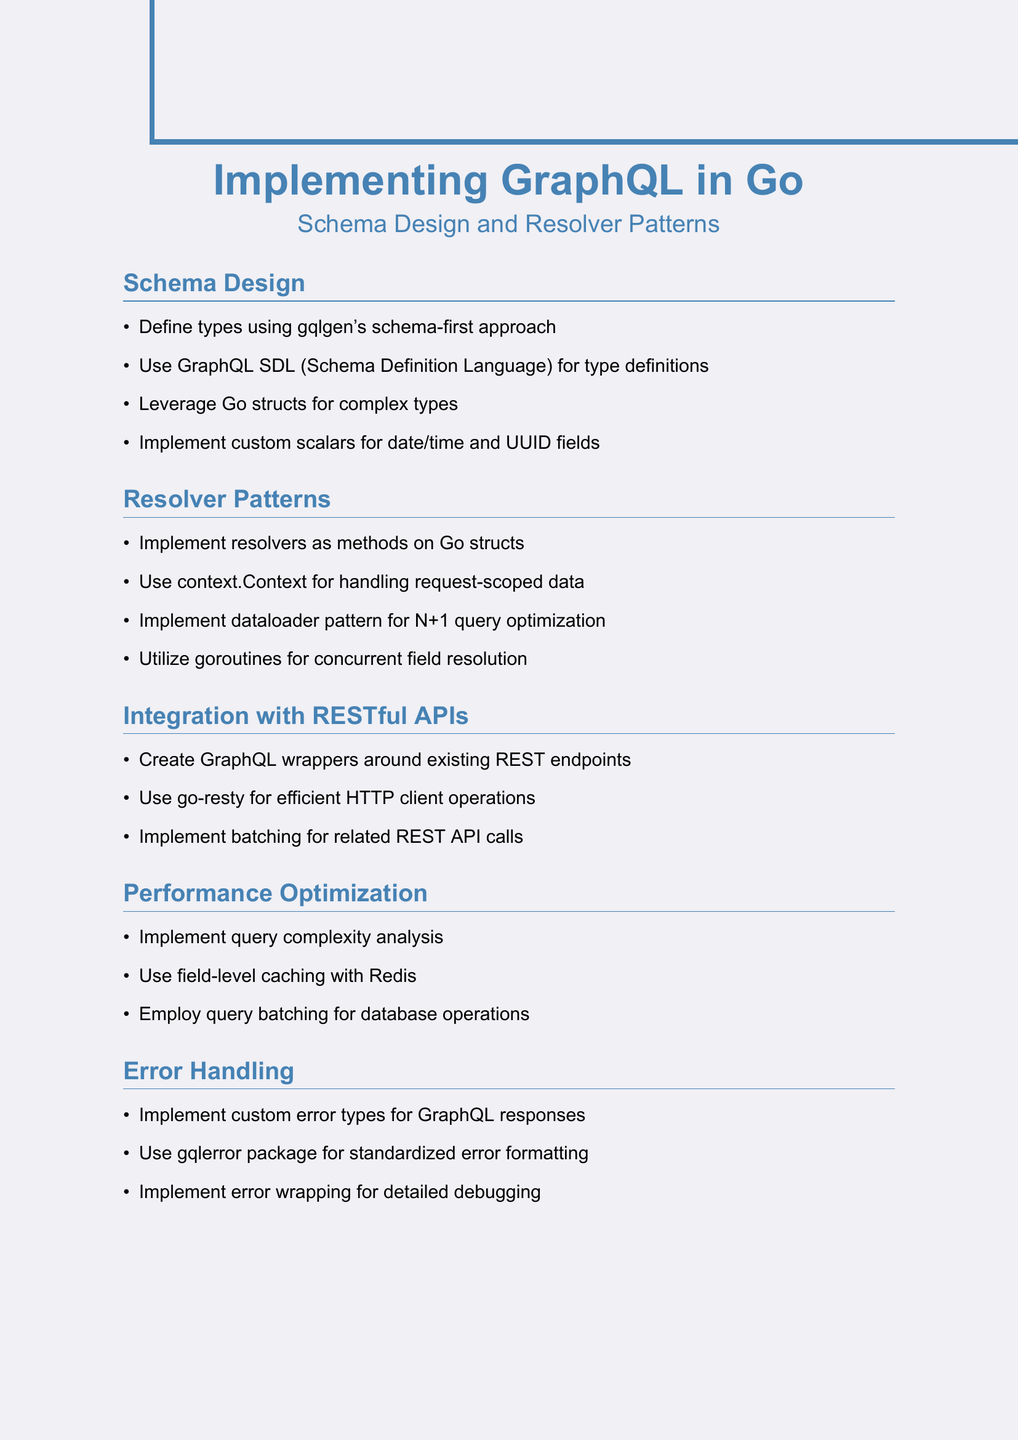What is the title of the document? The title of the document is provided at the beginning of the notes.
Answer: Implementing GraphQL in Go: Schema Design and Resolver Patterns What is the primary purpose of using GraphQL SDL? The document mentions using GraphQL SDL for type definitions within the schema design section.
Answer: For type definitions What pattern is suggested for handling request-scoped data? This information is found in the resolver patterns section of the document, indicating the use of context.Context.
Answer: context.Context What is a recommended technique for optimizing N+1 queries? The document highlights the dataloader pattern as a way to optimize N+1 queries in the resolver patterns.
Answer: dataloader pattern Which package is mentioned for standardized error formatting? The document specifies the gqlerror package for standardized error formatting in the error handling section.
Answer: gqlerror How should custom scalars be implemented? The schema design section indicates implementing custom scalars specifically for particular field types.
Answer: For date/time and UUID fields What caching technology is recommended for performance optimization? The document recommends using Redis for field-level caching in the performance optimization section.
Answer: Redis Which HTTP client library is suggested for efficient operations? The integration with RESTful APIs section mentions the go-resty library for efficient HTTP client operations.
Answer: go-resty How are the resolvers implemented according to the notes? The notes explain that resolvers should be implemented as methods on Go structs in the resolver patterns section.
Answer: As methods on Go structs 